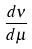<formula> <loc_0><loc_0><loc_500><loc_500>\frac { d \nu } { d \mu }</formula> 